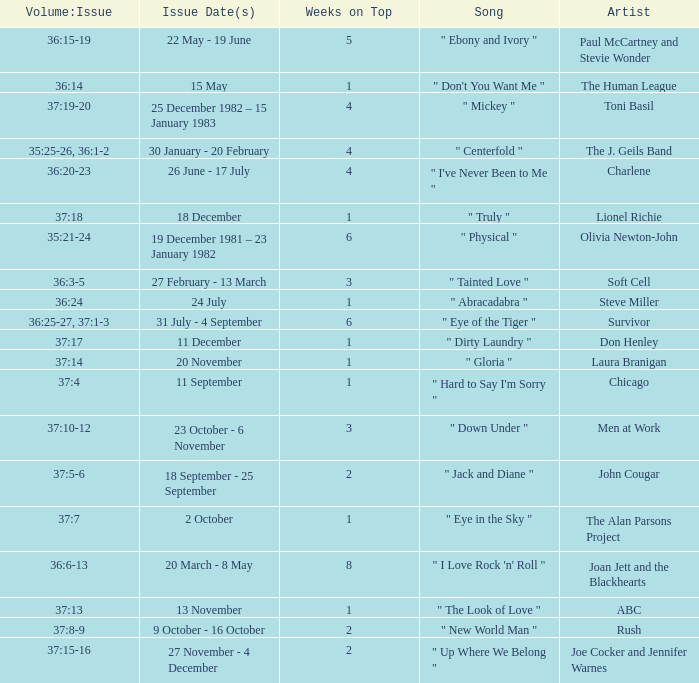Which Issue Date(s) has an Artist of men at work? 23 October - 6 November. 